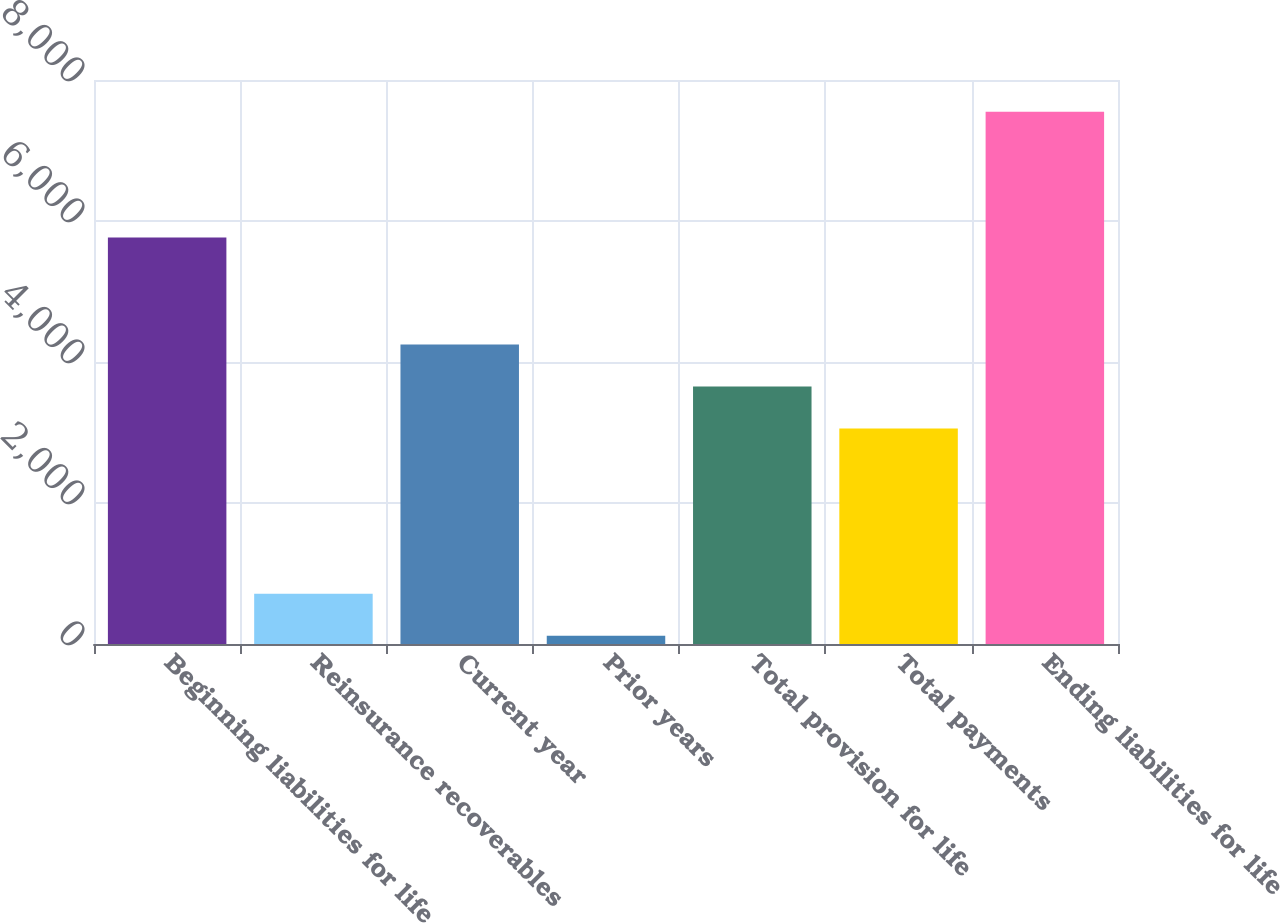<chart> <loc_0><loc_0><loc_500><loc_500><bar_chart><fcel>Beginning liabilities for life<fcel>Reinsurance recoverables<fcel>Current year<fcel>Prior years<fcel>Total provision for life<fcel>Total payments<fcel>Ending liabilities for life<nl><fcel>5767<fcel>712.8<fcel>4246.6<fcel>118<fcel>3651.8<fcel>3057<fcel>7551.4<nl></chart> 